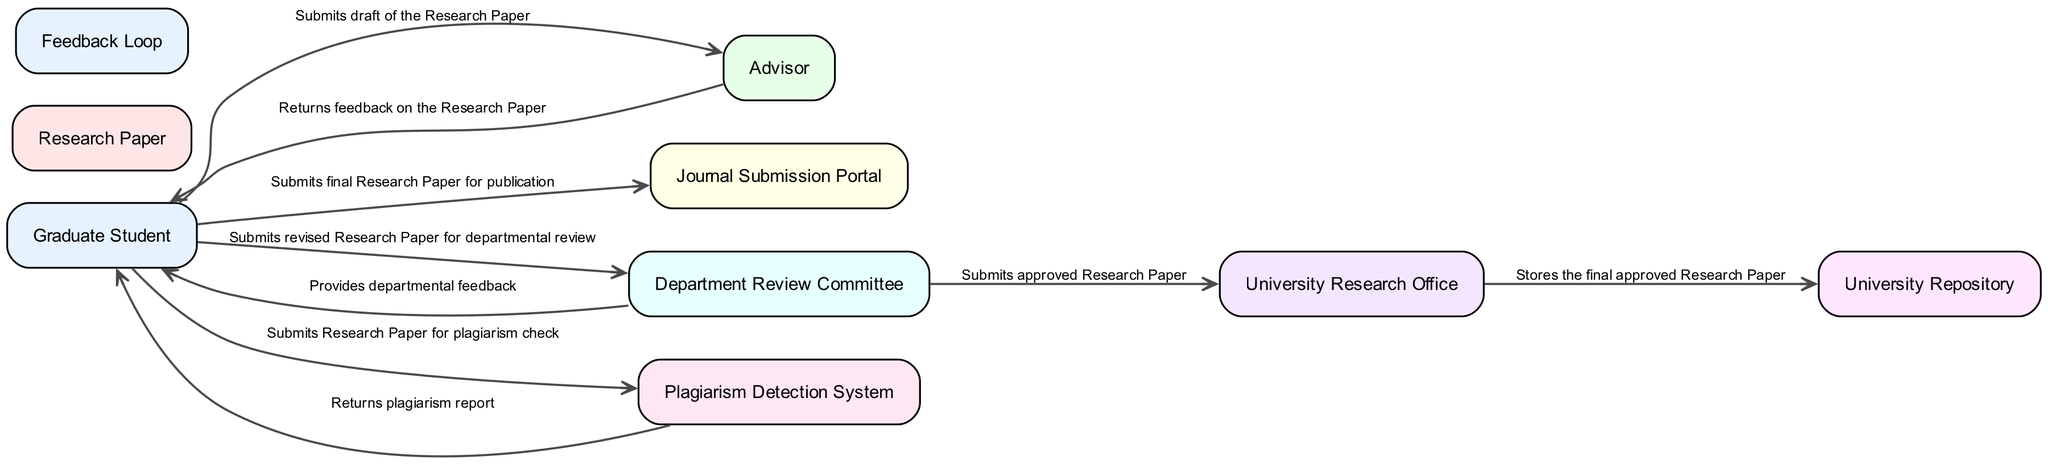What is the main actor in the workflow? The main actor in the workflow is the Graduate Student who prepares and submits the research paper.
Answer: Graduate Student How many entities are involved in the diagram? By counting the entities listed in the diagram, we find there are 9 unique entities involved in the workflow process.
Answer: 9 What document is prepared by the Graduate Student? The Graduate Student prepares a document known as the Research Paper, which contains the research findings.
Answer: Research Paper Which node provides feedback to the Graduate Student after paper submission? After submitting the draft of the Research Paper, the Advisor provides feedback to the Graduate Student in response to their submission.
Answer: Advisor What is submitted to the Plagiarism Detection System? The Graduate Student submits the Research Paper to the Plagiarism Detection System for checking originality before it undergoes further review.
Answer: Research Paper Describe the feedback loop in the workflow. The feedback loop involves the Advisor and Department Review Committee providing feedback to the Graduate Student after reviewing the draft and the revised paper, respectively.
Answer: Feedback Loop How does the Department Review Committee interact with the University Research Office? The Department Review Committee submits the approved Research Paper to the University Research Office for further processing and final approval, demonstrating the flow of communication between these two entities.
Answer: Submits approved Research Paper What happens to the final approved Research Paper? After obtaining final approval from the University Research Office, the final approved Research Paper is stored in the University Repository, ensuring it is archived in a central digital location.
Answer: Stored in University Repository Which platform does the Graduate Student use to submit the final Research Paper for publication? The Graduate Student submits the final Research Paper for publication through the Journal Submission Portal, serving as the online platform for this purpose.
Answer: Journal Submission Portal 